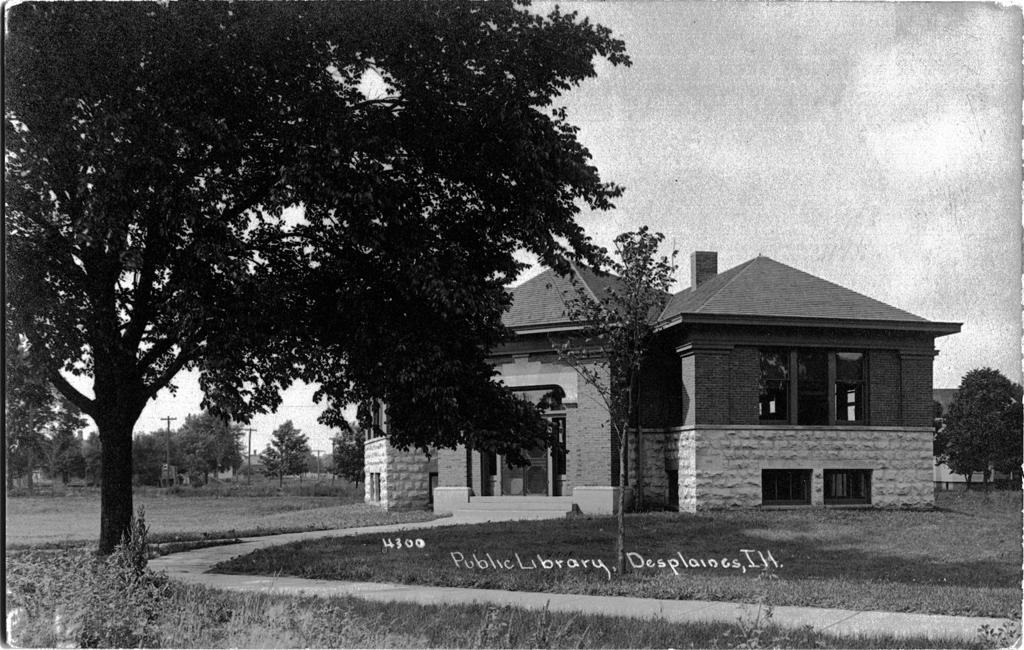What type of vegetation can be seen in the image? There are trees in the image. What can be seen beneath the trees? The ground is visible in the image. What man-made structure is present in the image? There is an electrical pole in the image. What part of the natural environment is visible in the image? The sky is visible in the image. What type of buildings can be seen in the image? There are houses in the image. Can you describe a specific feature of one of the houses? There is a root leading to a house in the image. How many ants are visible on the electrical pole in the image? There are no ants visible on the electrical pole in the image. What type of servant can be seen working in one of the houses in the image? There are no servants visible in the image, nor is there any indication of someone working inside a house. 